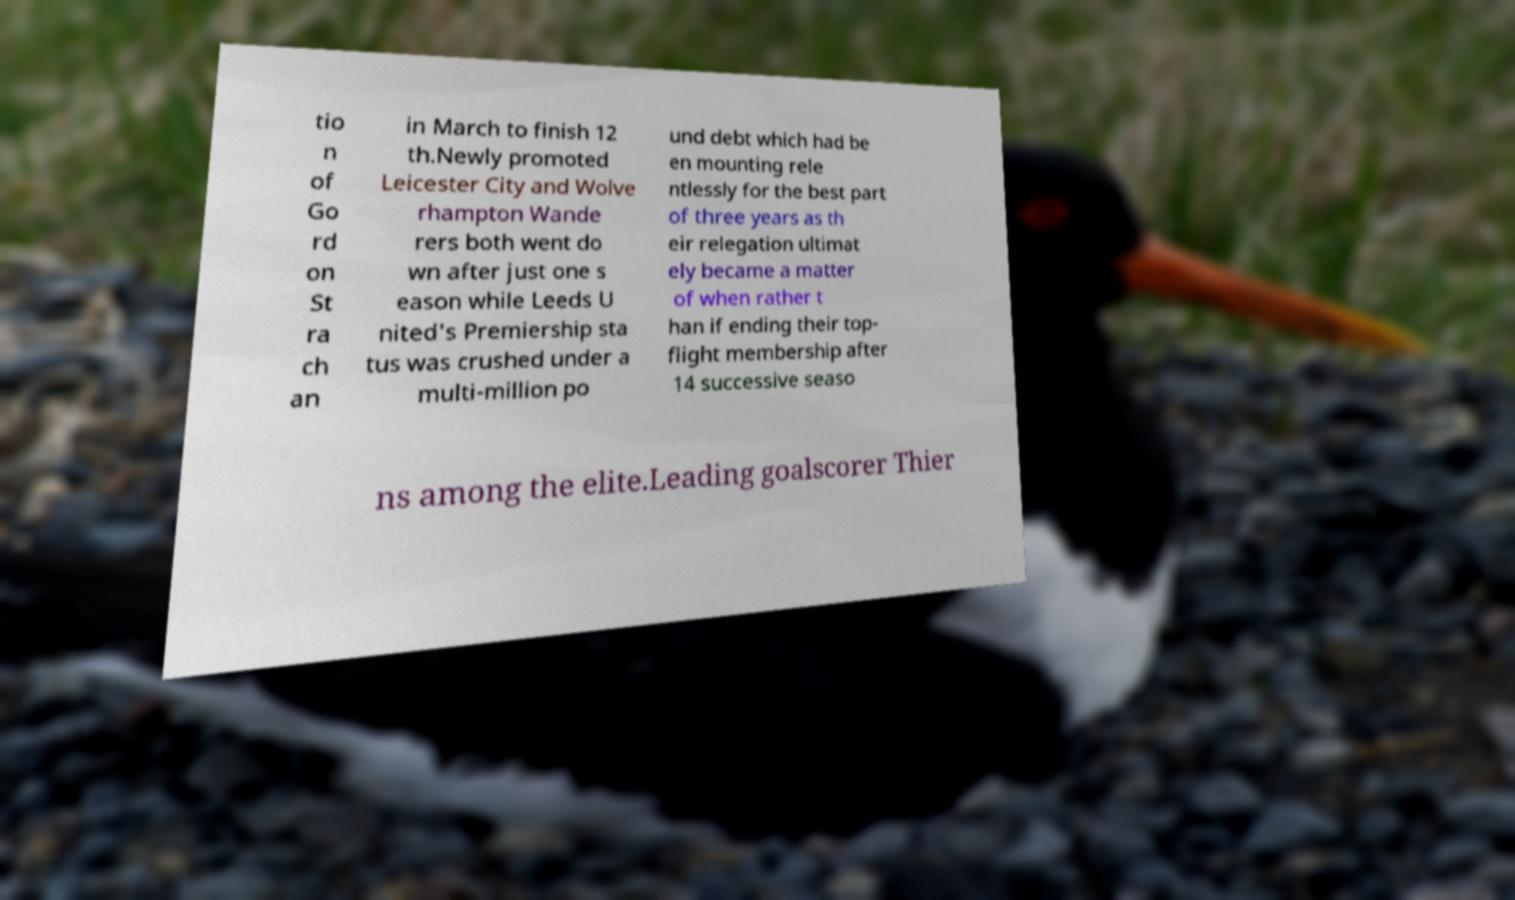Could you assist in decoding the text presented in this image and type it out clearly? tio n of Go rd on St ra ch an in March to finish 12 th.Newly promoted Leicester City and Wolve rhampton Wande rers both went do wn after just one s eason while Leeds U nited's Premiership sta tus was crushed under a multi-million po und debt which had be en mounting rele ntlessly for the best part of three years as th eir relegation ultimat ely became a matter of when rather t han if ending their top- flight membership after 14 successive seaso ns among the elite.Leading goalscorer Thier 